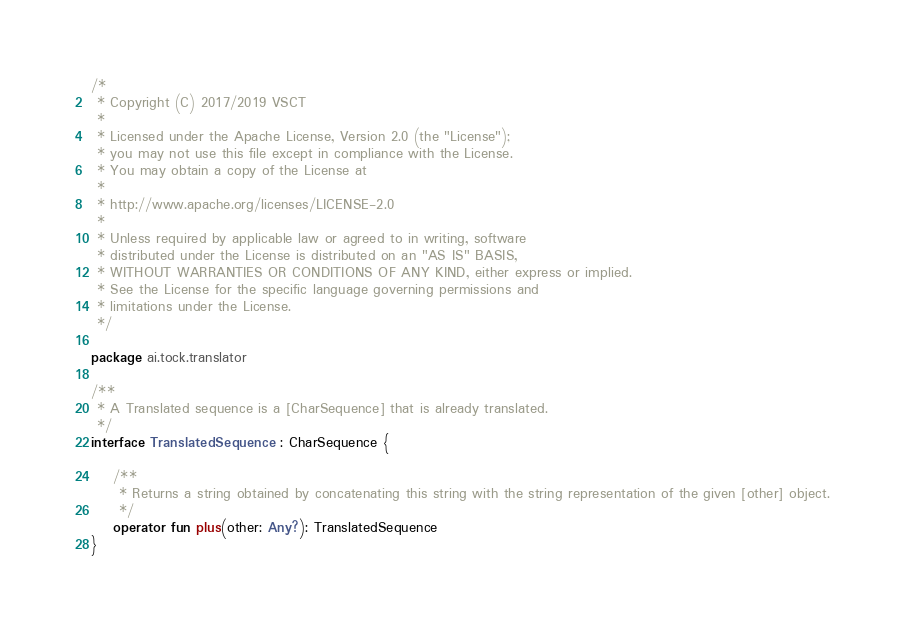Convert code to text. <code><loc_0><loc_0><loc_500><loc_500><_Kotlin_>/*
 * Copyright (C) 2017/2019 VSCT
 *
 * Licensed under the Apache License, Version 2.0 (the "License");
 * you may not use this file except in compliance with the License.
 * You may obtain a copy of the License at
 *
 * http://www.apache.org/licenses/LICENSE-2.0
 *
 * Unless required by applicable law or agreed to in writing, software
 * distributed under the License is distributed on an "AS IS" BASIS,
 * WITHOUT WARRANTIES OR CONDITIONS OF ANY KIND, either express or implied.
 * See the License for the specific language governing permissions and
 * limitations under the License.
 */

package ai.tock.translator

/**
 * A Translated sequence is a [CharSequence] that is already translated.
 */
interface TranslatedSequence : CharSequence {

    /**
     * Returns a string obtained by concatenating this string with the string representation of the given [other] object.
     */
    operator fun plus(other: Any?): TranslatedSequence
}</code> 